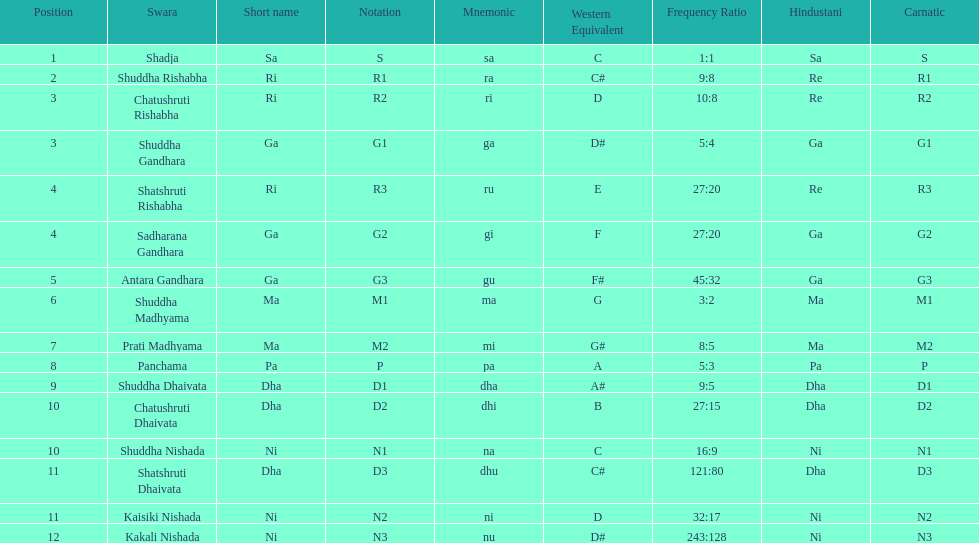How many swaras do not have dhaivata in their name? 13. 